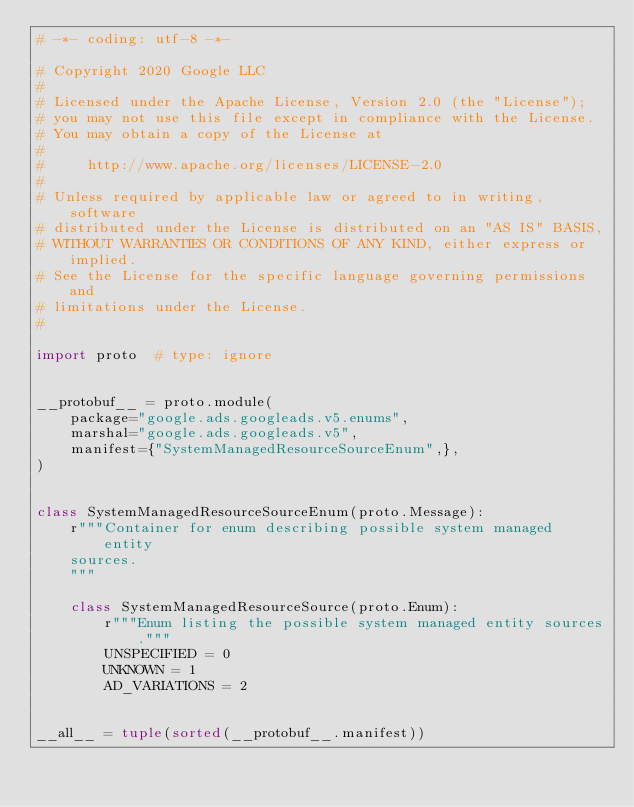Convert code to text. <code><loc_0><loc_0><loc_500><loc_500><_Python_># -*- coding: utf-8 -*-

# Copyright 2020 Google LLC
#
# Licensed under the Apache License, Version 2.0 (the "License");
# you may not use this file except in compliance with the License.
# You may obtain a copy of the License at
#
#     http://www.apache.org/licenses/LICENSE-2.0
#
# Unless required by applicable law or agreed to in writing, software
# distributed under the License is distributed on an "AS IS" BASIS,
# WITHOUT WARRANTIES OR CONDITIONS OF ANY KIND, either express or implied.
# See the License for the specific language governing permissions and
# limitations under the License.
#

import proto  # type: ignore


__protobuf__ = proto.module(
    package="google.ads.googleads.v5.enums",
    marshal="google.ads.googleads.v5",
    manifest={"SystemManagedResourceSourceEnum",},
)


class SystemManagedResourceSourceEnum(proto.Message):
    r"""Container for enum describing possible system managed entity
    sources.
    """

    class SystemManagedResourceSource(proto.Enum):
        r"""Enum listing the possible system managed entity sources."""
        UNSPECIFIED = 0
        UNKNOWN = 1
        AD_VARIATIONS = 2


__all__ = tuple(sorted(__protobuf__.manifest))
</code> 